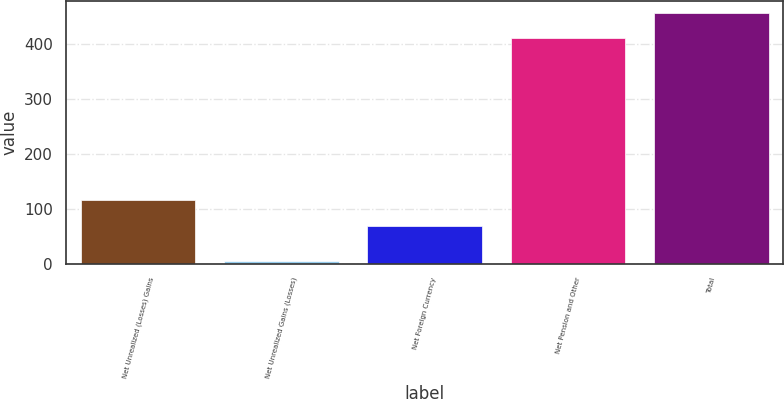<chart> <loc_0><loc_0><loc_500><loc_500><bar_chart><fcel>Net Unrealized (Losses) Gains<fcel>Net Unrealized Gains (Losses)<fcel>Net Foreign Currency<fcel>Net Pension and Other<fcel>Total<nl><fcel>114.9<fcel>4<fcel>67.9<fcel>410.7<fcel>455.67<nl></chart> 